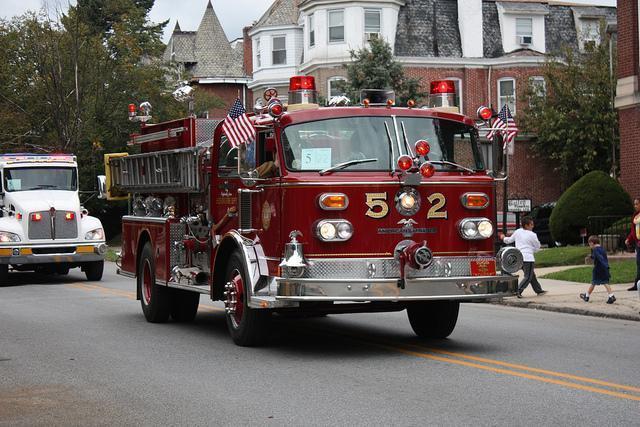What country's flag can be seen on the truck?
Answer the question by selecting the correct answer among the 4 following choices and explain your choice with a short sentence. The answer should be formatted with the following format: `Answer: choice
Rationale: rationale.`
Options: Italy, america, france, spain. Answer: america.
Rationale: There are stars and stripes on the flag. 